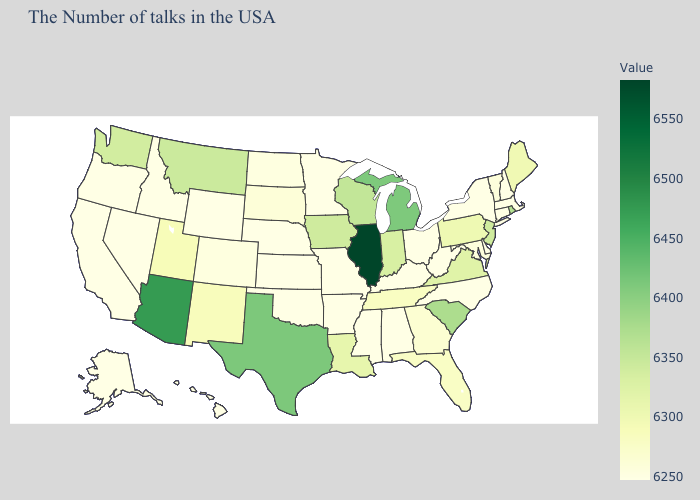Which states hav the highest value in the West?
Be succinct. Arizona. Does New York have the lowest value in the USA?
Short answer required. Yes. Among the states that border Tennessee , does Georgia have the lowest value?
Write a very short answer. No. 